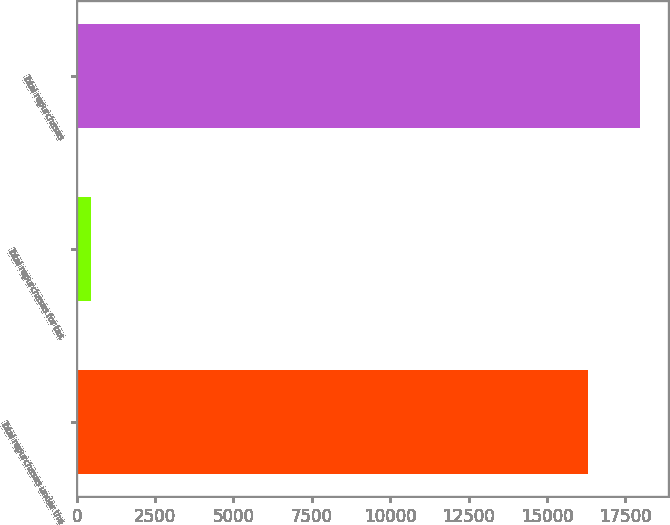Convert chart. <chart><loc_0><loc_0><loc_500><loc_500><bar_chart><fcel>Total repurchases under the<fcel>Total repurchases for tax<fcel>Total repurchases<nl><fcel>16318<fcel>465<fcel>17949.8<nl></chart> 